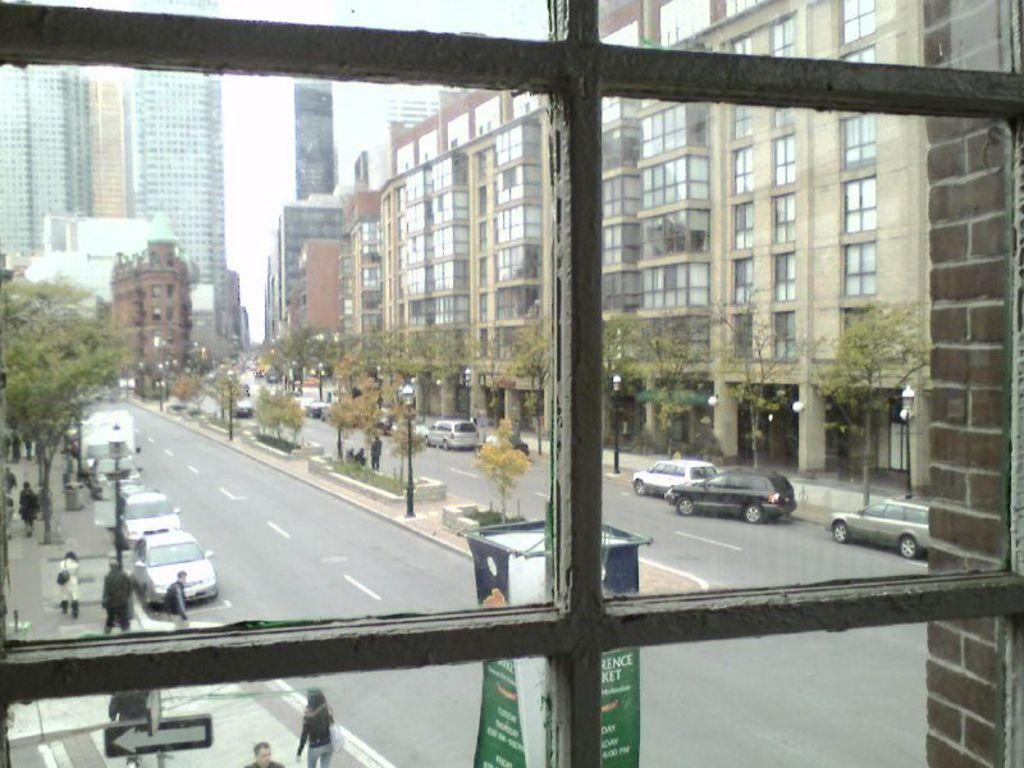How many people are present in the image? There is a group of people in the image, but the exact number cannot be determined from the provided facts. What types of vehicles can be seen in the image? Vehicles are present in the image, but their specific types cannot be determined from the provided facts. What kind of natural elements are visible in the image? Trees are visible in the image. What type of man-made structures are present in the image? Buildings are present in the image. What are the poles used for in the image? The purpose of the poles cannot be determined from the provided facts. What are the lights used for in the image? The purpose of the lights cannot be determined from the provided facts. What type of advertising or signage is present in the image? Hoardings are present in the image. How many lizards are playing chess on the gold table in the image? There are no lizards, chess, or gold table present in the image. 